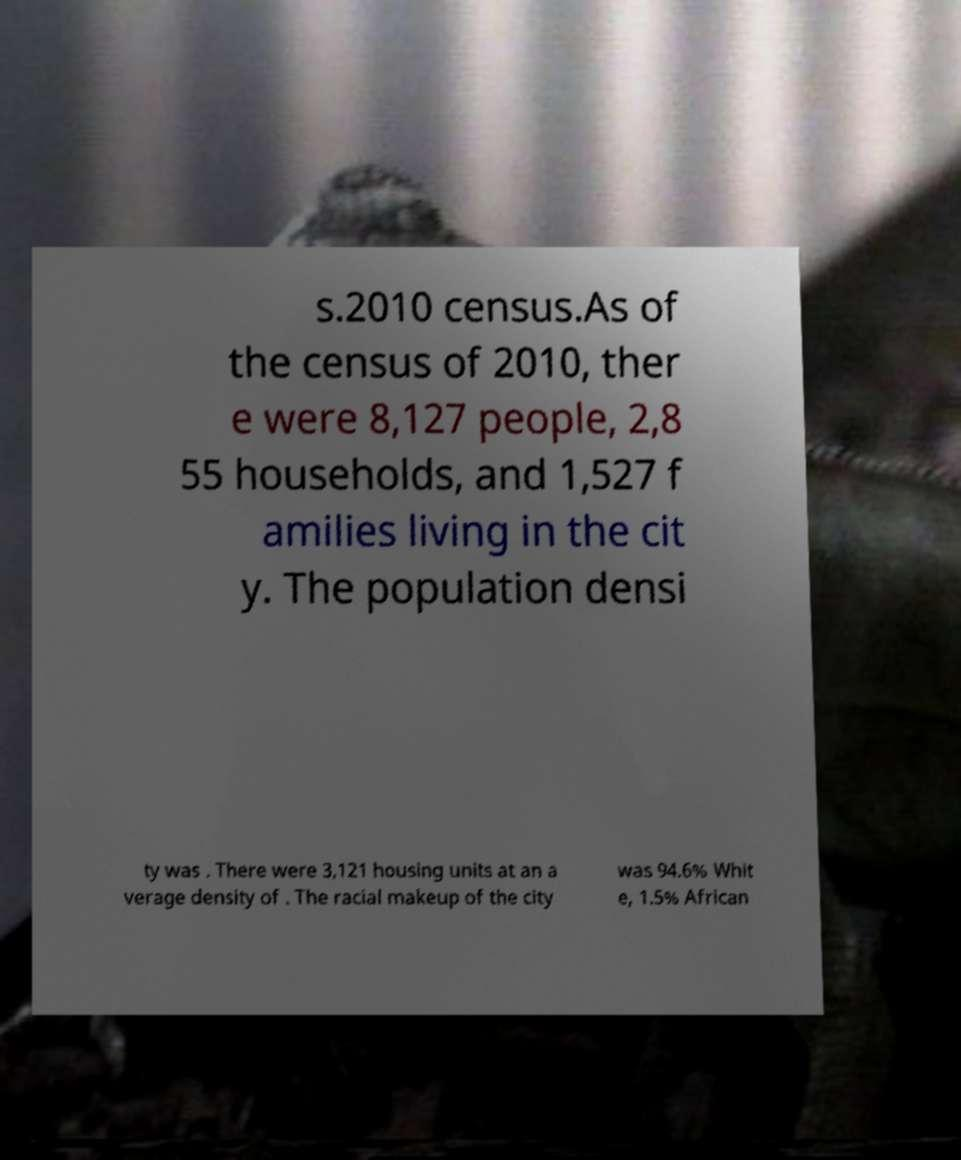For documentation purposes, I need the text within this image transcribed. Could you provide that? s.2010 census.As of the census of 2010, ther e were 8,127 people, 2,8 55 households, and 1,527 f amilies living in the cit y. The population densi ty was . There were 3,121 housing units at an a verage density of . The racial makeup of the city was 94.6% Whit e, 1.5% African 